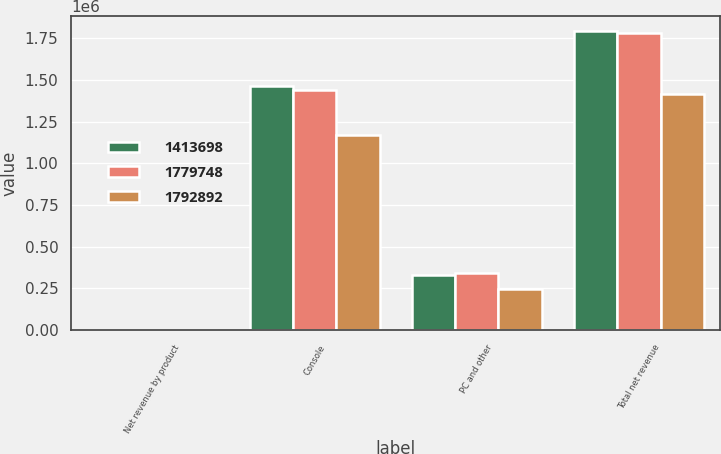Convert chart. <chart><loc_0><loc_0><loc_500><loc_500><stacked_bar_chart><ecel><fcel>Net revenue by product<fcel>Console<fcel>PC and other<fcel>Total net revenue<nl><fcel>1.4137e+06<fcel>2018<fcel>1.46331e+06<fcel>329586<fcel>1.79289e+06<nl><fcel>1.77975e+06<fcel>2017<fcel>1.44072e+06<fcel>339024<fcel>1.77975e+06<nl><fcel>1.79289e+06<fcel>2016<fcel>1.16762e+06<fcel>246075<fcel>1.4137e+06<nl></chart> 